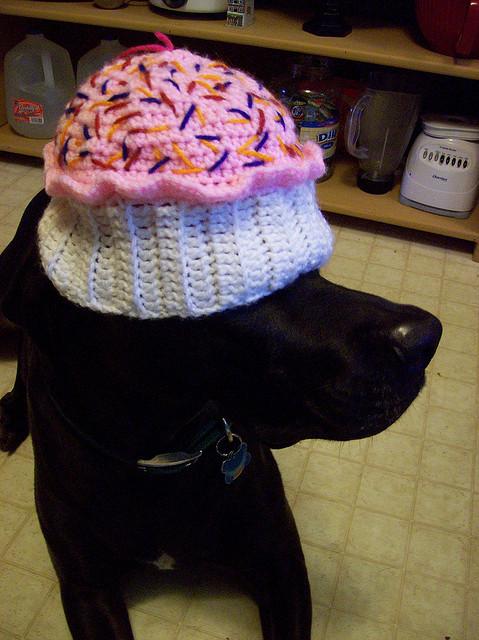What is the dog wearing?
Concise answer only. Hat. What color is the dog?
Be succinct. Black. What color is the woman's hat?
Quick response, please. Pink and white. Is this a real animal?
Be succinct. Yes. Is this a teddy bear?
Quick response, please. No. What is around the dog's mouth?
Quick response, please. Nothing. What is sitting in the middle of the rug?
Give a very brief answer. Dog. What type of dog is this?
Write a very short answer. Lab. Does the dog have a tag on?
Concise answer only. Yes. 